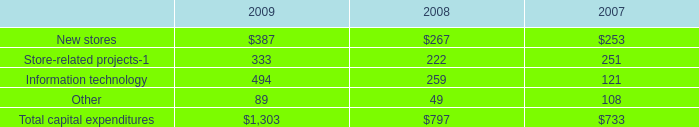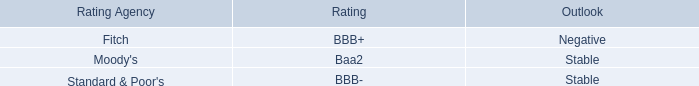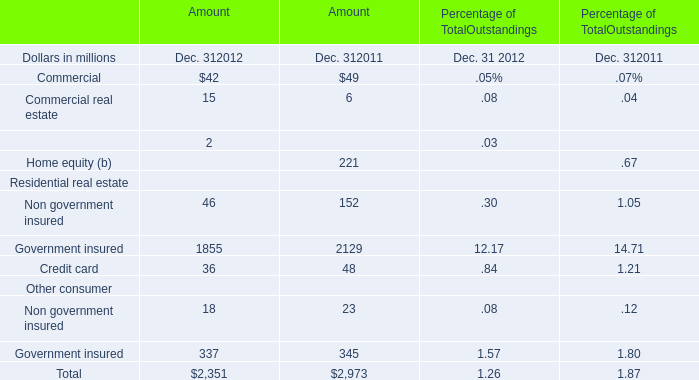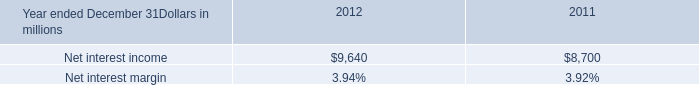What is the growing rate of credit card in the years with the least government insured? (in %) 
Computations: ((36 - 48) / 48)
Answer: -0.25. 